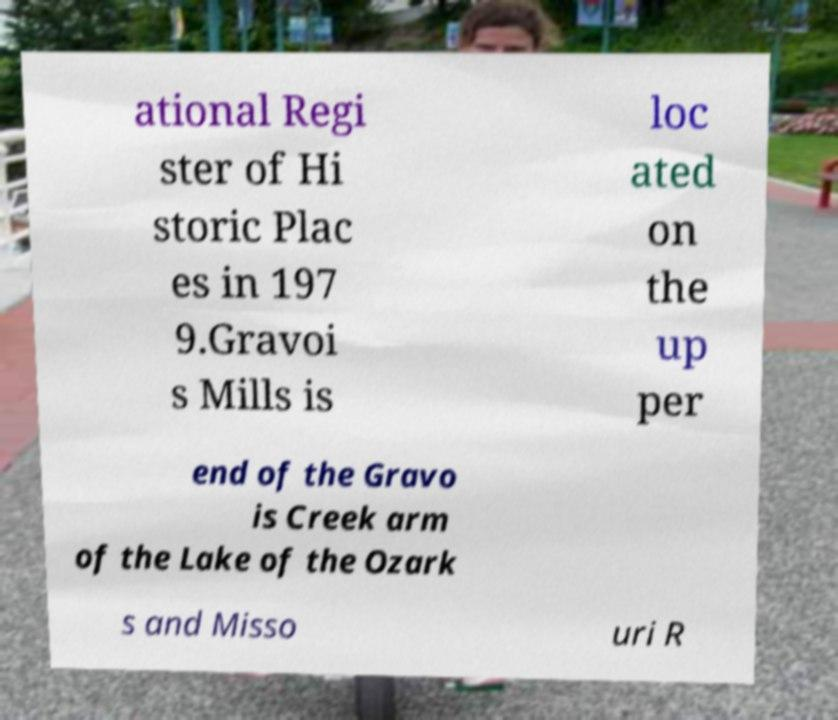There's text embedded in this image that I need extracted. Can you transcribe it verbatim? ational Regi ster of Hi storic Plac es in 197 9.Gravoi s Mills is loc ated on the up per end of the Gravo is Creek arm of the Lake of the Ozark s and Misso uri R 